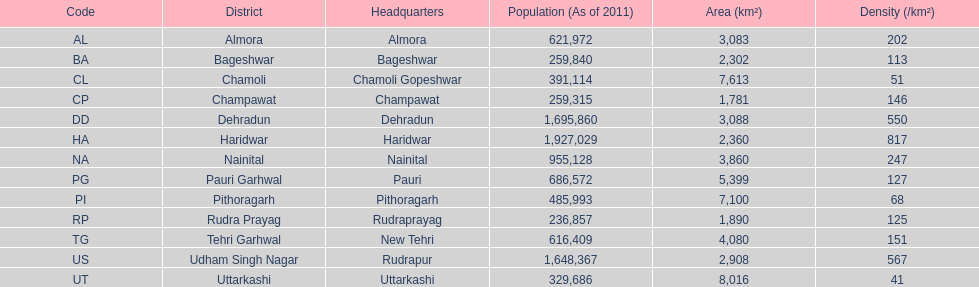Which headquarters shares its district name and has a population density of 202? Almora. 